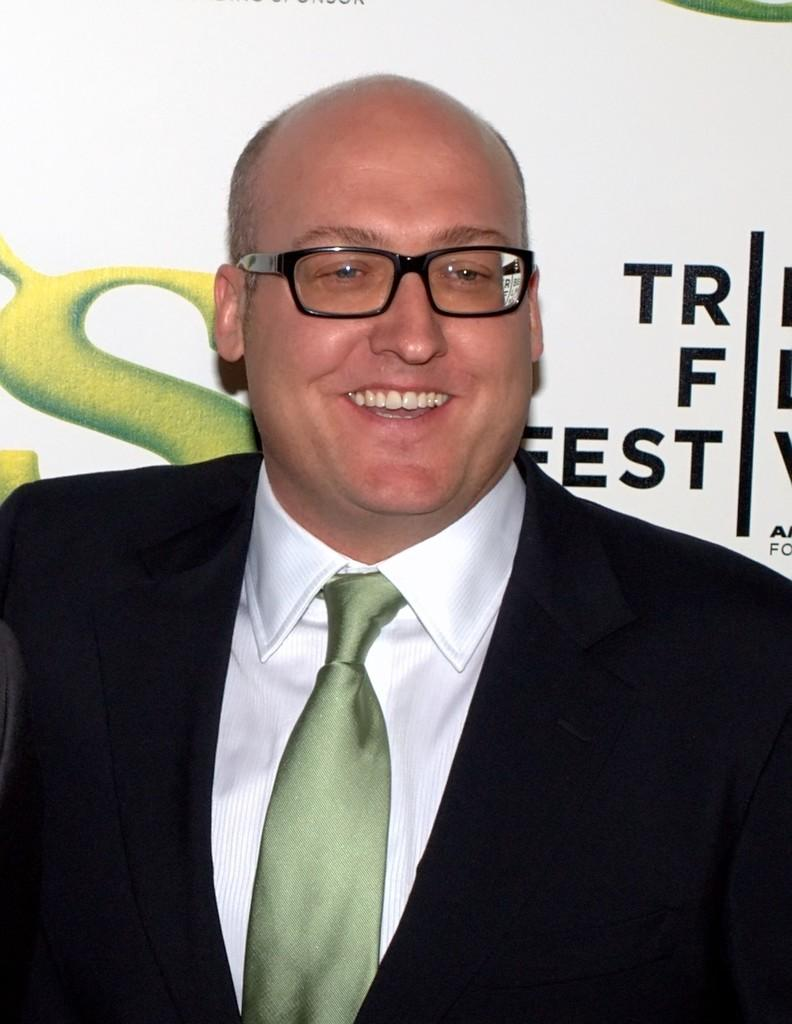Who is present in the image? There is a man in the image. What is the man's facial expression? The man is smiling. What is the man wearing? The man is wearing a suit and spectacles. What can be seen in the background of the image? There is text visible in the background of the image. What type of beast is the man joking with in the image? There is no beast present in the image, and the man is not depicted as joking with anyone or anything. 